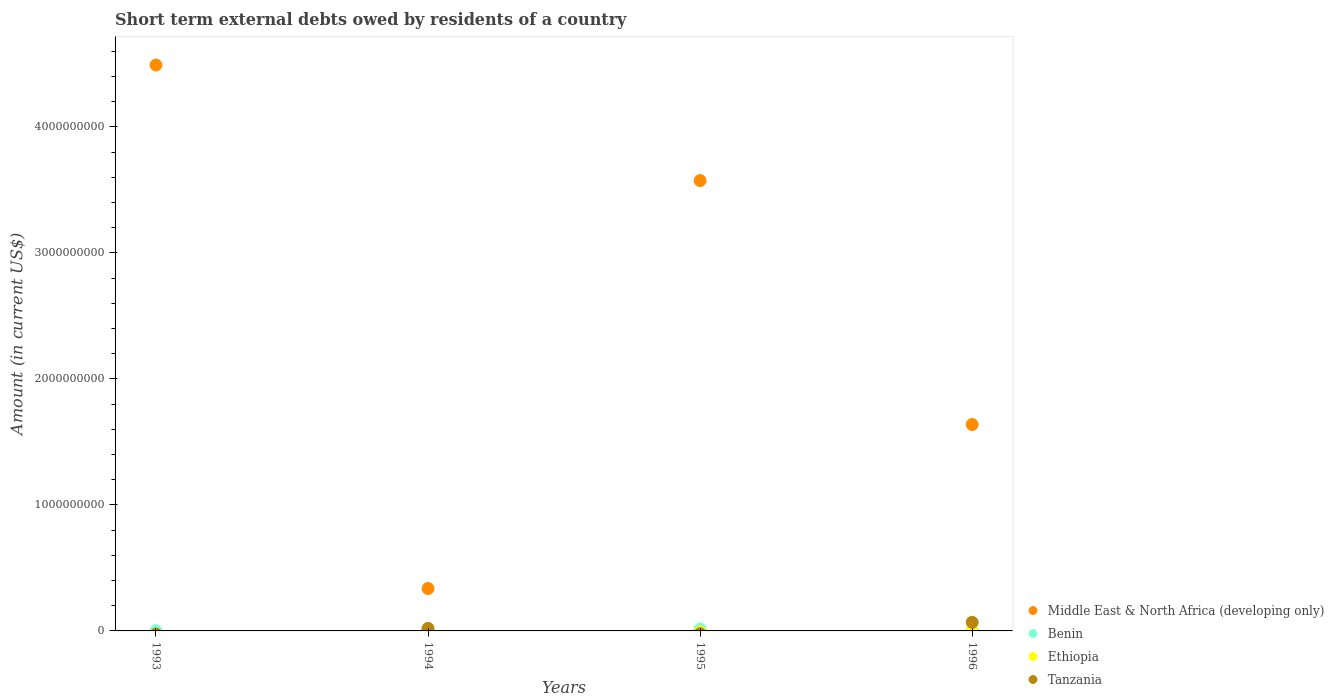Is the number of dotlines equal to the number of legend labels?
Your answer should be very brief. No. What is the amount of short-term external debts owed by residents in Benin in 1995?
Offer a terse response. 1.60e+07. Across all years, what is the maximum amount of short-term external debts owed by residents in Tanzania?
Provide a succinct answer. 6.81e+07. Across all years, what is the minimum amount of short-term external debts owed by residents in Middle East & North Africa (developing only)?
Ensure brevity in your answer.  3.36e+08. In which year was the amount of short-term external debts owed by residents in Middle East & North Africa (developing only) maximum?
Your response must be concise. 1993. What is the total amount of short-term external debts owed by residents in Benin in the graph?
Your response must be concise. 2.07e+07. What is the difference between the amount of short-term external debts owed by residents in Middle East & North Africa (developing only) in 1995 and that in 1996?
Your response must be concise. 1.94e+09. What is the difference between the amount of short-term external debts owed by residents in Middle East & North Africa (developing only) in 1994 and the amount of short-term external debts owed by residents in Tanzania in 1995?
Ensure brevity in your answer.  3.36e+08. What is the average amount of short-term external debts owed by residents in Tanzania per year?
Offer a very short reply. 2.20e+07. In the year 1993, what is the difference between the amount of short-term external debts owed by residents in Middle East & North Africa (developing only) and amount of short-term external debts owed by residents in Benin?
Make the answer very short. 4.49e+09. In how many years, is the amount of short-term external debts owed by residents in Middle East & North Africa (developing only) greater than 2000000000 US$?
Offer a very short reply. 2. What is the ratio of the amount of short-term external debts owed by residents in Middle East & North Africa (developing only) in 1995 to that in 1996?
Provide a short and direct response. 2.18. Is the amount of short-term external debts owed by residents in Benin in 1994 less than that in 1995?
Ensure brevity in your answer.  Yes. What is the difference between the highest and the second highest amount of short-term external debts owed by residents in Benin?
Your response must be concise. 1.33e+07. What is the difference between the highest and the lowest amount of short-term external debts owed by residents in Benin?
Offer a very short reply. 1.60e+07. Is the sum of the amount of short-term external debts owed by residents in Middle East & North Africa (developing only) in 1993 and 1996 greater than the maximum amount of short-term external debts owed by residents in Tanzania across all years?
Ensure brevity in your answer.  Yes. Does the amount of short-term external debts owed by residents in Ethiopia monotonically increase over the years?
Give a very brief answer. No. How many dotlines are there?
Offer a very short reply. 4. Are the values on the major ticks of Y-axis written in scientific E-notation?
Offer a very short reply. No. Does the graph contain grids?
Your answer should be very brief. No. Where does the legend appear in the graph?
Your answer should be compact. Bottom right. How many legend labels are there?
Make the answer very short. 4. How are the legend labels stacked?
Provide a succinct answer. Vertical. What is the title of the graph?
Ensure brevity in your answer.  Short term external debts owed by residents of a country. What is the label or title of the X-axis?
Keep it short and to the point. Years. What is the Amount (in current US$) in Middle East & North Africa (developing only) in 1993?
Keep it short and to the point. 4.49e+09. What is the Amount (in current US$) in Benin in 1993?
Provide a short and direct response. 1.97e+06. What is the Amount (in current US$) of Ethiopia in 1993?
Your answer should be compact. 0. What is the Amount (in current US$) of Middle East & North Africa (developing only) in 1994?
Keep it short and to the point. 3.36e+08. What is the Amount (in current US$) in Benin in 1994?
Give a very brief answer. 2.71e+06. What is the Amount (in current US$) of Ethiopia in 1994?
Your answer should be very brief. 2.30e+05. What is the Amount (in current US$) in Tanzania in 1994?
Ensure brevity in your answer.  1.99e+07. What is the Amount (in current US$) in Middle East & North Africa (developing only) in 1995?
Your answer should be very brief. 3.57e+09. What is the Amount (in current US$) in Benin in 1995?
Offer a very short reply. 1.60e+07. What is the Amount (in current US$) in Tanzania in 1995?
Provide a succinct answer. 0. What is the Amount (in current US$) in Middle East & North Africa (developing only) in 1996?
Provide a short and direct response. 1.64e+09. What is the Amount (in current US$) in Tanzania in 1996?
Ensure brevity in your answer.  6.81e+07. Across all years, what is the maximum Amount (in current US$) of Middle East & North Africa (developing only)?
Your answer should be very brief. 4.49e+09. Across all years, what is the maximum Amount (in current US$) of Benin?
Give a very brief answer. 1.60e+07. Across all years, what is the maximum Amount (in current US$) in Ethiopia?
Your answer should be compact. 2.30e+05. Across all years, what is the maximum Amount (in current US$) in Tanzania?
Your answer should be compact. 6.81e+07. Across all years, what is the minimum Amount (in current US$) in Middle East & North Africa (developing only)?
Give a very brief answer. 3.36e+08. Across all years, what is the minimum Amount (in current US$) of Ethiopia?
Offer a very short reply. 0. What is the total Amount (in current US$) of Middle East & North Africa (developing only) in the graph?
Keep it short and to the point. 1.00e+1. What is the total Amount (in current US$) in Benin in the graph?
Your answer should be very brief. 2.07e+07. What is the total Amount (in current US$) in Ethiopia in the graph?
Make the answer very short. 2.30e+05. What is the total Amount (in current US$) of Tanzania in the graph?
Give a very brief answer. 8.80e+07. What is the difference between the Amount (in current US$) of Middle East & North Africa (developing only) in 1993 and that in 1994?
Ensure brevity in your answer.  4.15e+09. What is the difference between the Amount (in current US$) in Benin in 1993 and that in 1994?
Your answer should be compact. -7.40e+05. What is the difference between the Amount (in current US$) of Middle East & North Africa (developing only) in 1993 and that in 1995?
Your answer should be very brief. 9.17e+08. What is the difference between the Amount (in current US$) of Benin in 1993 and that in 1995?
Ensure brevity in your answer.  -1.40e+07. What is the difference between the Amount (in current US$) in Middle East & North Africa (developing only) in 1993 and that in 1996?
Offer a terse response. 2.85e+09. What is the difference between the Amount (in current US$) in Middle East & North Africa (developing only) in 1994 and that in 1995?
Your answer should be very brief. -3.24e+09. What is the difference between the Amount (in current US$) in Benin in 1994 and that in 1995?
Offer a very short reply. -1.33e+07. What is the difference between the Amount (in current US$) in Middle East & North Africa (developing only) in 1994 and that in 1996?
Provide a short and direct response. -1.30e+09. What is the difference between the Amount (in current US$) in Tanzania in 1994 and that in 1996?
Ensure brevity in your answer.  -4.82e+07. What is the difference between the Amount (in current US$) in Middle East & North Africa (developing only) in 1995 and that in 1996?
Provide a short and direct response. 1.94e+09. What is the difference between the Amount (in current US$) of Middle East & North Africa (developing only) in 1993 and the Amount (in current US$) of Benin in 1994?
Keep it short and to the point. 4.49e+09. What is the difference between the Amount (in current US$) in Middle East & North Africa (developing only) in 1993 and the Amount (in current US$) in Ethiopia in 1994?
Ensure brevity in your answer.  4.49e+09. What is the difference between the Amount (in current US$) of Middle East & North Africa (developing only) in 1993 and the Amount (in current US$) of Tanzania in 1994?
Offer a very short reply. 4.47e+09. What is the difference between the Amount (in current US$) in Benin in 1993 and the Amount (in current US$) in Ethiopia in 1994?
Your answer should be very brief. 1.74e+06. What is the difference between the Amount (in current US$) in Benin in 1993 and the Amount (in current US$) in Tanzania in 1994?
Give a very brief answer. -1.79e+07. What is the difference between the Amount (in current US$) of Middle East & North Africa (developing only) in 1993 and the Amount (in current US$) of Benin in 1995?
Make the answer very short. 4.47e+09. What is the difference between the Amount (in current US$) of Middle East & North Africa (developing only) in 1993 and the Amount (in current US$) of Tanzania in 1996?
Make the answer very short. 4.42e+09. What is the difference between the Amount (in current US$) in Benin in 1993 and the Amount (in current US$) in Tanzania in 1996?
Give a very brief answer. -6.61e+07. What is the difference between the Amount (in current US$) of Middle East & North Africa (developing only) in 1994 and the Amount (in current US$) of Benin in 1995?
Provide a short and direct response. 3.20e+08. What is the difference between the Amount (in current US$) in Middle East & North Africa (developing only) in 1994 and the Amount (in current US$) in Tanzania in 1996?
Ensure brevity in your answer.  2.68e+08. What is the difference between the Amount (in current US$) of Benin in 1994 and the Amount (in current US$) of Tanzania in 1996?
Ensure brevity in your answer.  -6.54e+07. What is the difference between the Amount (in current US$) of Ethiopia in 1994 and the Amount (in current US$) of Tanzania in 1996?
Provide a short and direct response. -6.78e+07. What is the difference between the Amount (in current US$) in Middle East & North Africa (developing only) in 1995 and the Amount (in current US$) in Tanzania in 1996?
Provide a short and direct response. 3.51e+09. What is the difference between the Amount (in current US$) in Benin in 1995 and the Amount (in current US$) in Tanzania in 1996?
Offer a very short reply. -5.21e+07. What is the average Amount (in current US$) in Middle East & North Africa (developing only) per year?
Give a very brief answer. 2.51e+09. What is the average Amount (in current US$) in Benin per year?
Your answer should be compact. 5.16e+06. What is the average Amount (in current US$) of Ethiopia per year?
Provide a succinct answer. 5.75e+04. What is the average Amount (in current US$) in Tanzania per year?
Your response must be concise. 2.20e+07. In the year 1993, what is the difference between the Amount (in current US$) in Middle East & North Africa (developing only) and Amount (in current US$) in Benin?
Ensure brevity in your answer.  4.49e+09. In the year 1994, what is the difference between the Amount (in current US$) in Middle East & North Africa (developing only) and Amount (in current US$) in Benin?
Offer a terse response. 3.34e+08. In the year 1994, what is the difference between the Amount (in current US$) of Middle East & North Africa (developing only) and Amount (in current US$) of Ethiopia?
Offer a very short reply. 3.36e+08. In the year 1994, what is the difference between the Amount (in current US$) of Middle East & North Africa (developing only) and Amount (in current US$) of Tanzania?
Provide a short and direct response. 3.16e+08. In the year 1994, what is the difference between the Amount (in current US$) in Benin and Amount (in current US$) in Ethiopia?
Ensure brevity in your answer.  2.48e+06. In the year 1994, what is the difference between the Amount (in current US$) in Benin and Amount (in current US$) in Tanzania?
Offer a very short reply. -1.72e+07. In the year 1994, what is the difference between the Amount (in current US$) of Ethiopia and Amount (in current US$) of Tanzania?
Offer a very short reply. -1.97e+07. In the year 1995, what is the difference between the Amount (in current US$) of Middle East & North Africa (developing only) and Amount (in current US$) of Benin?
Provide a succinct answer. 3.56e+09. In the year 1996, what is the difference between the Amount (in current US$) in Middle East & North Africa (developing only) and Amount (in current US$) in Tanzania?
Make the answer very short. 1.57e+09. What is the ratio of the Amount (in current US$) of Middle East & North Africa (developing only) in 1993 to that in 1994?
Give a very brief answer. 13.35. What is the ratio of the Amount (in current US$) of Benin in 1993 to that in 1994?
Give a very brief answer. 0.73. What is the ratio of the Amount (in current US$) in Middle East & North Africa (developing only) in 1993 to that in 1995?
Your answer should be compact. 1.26. What is the ratio of the Amount (in current US$) in Benin in 1993 to that in 1995?
Make the answer very short. 0.12. What is the ratio of the Amount (in current US$) in Middle East & North Africa (developing only) in 1993 to that in 1996?
Keep it short and to the point. 2.74. What is the ratio of the Amount (in current US$) in Middle East & North Africa (developing only) in 1994 to that in 1995?
Your response must be concise. 0.09. What is the ratio of the Amount (in current US$) of Benin in 1994 to that in 1995?
Offer a very short reply. 0.17. What is the ratio of the Amount (in current US$) of Middle East & North Africa (developing only) in 1994 to that in 1996?
Provide a short and direct response. 0.21. What is the ratio of the Amount (in current US$) in Tanzania in 1994 to that in 1996?
Give a very brief answer. 0.29. What is the ratio of the Amount (in current US$) of Middle East & North Africa (developing only) in 1995 to that in 1996?
Keep it short and to the point. 2.18. What is the difference between the highest and the second highest Amount (in current US$) of Middle East & North Africa (developing only)?
Your response must be concise. 9.17e+08. What is the difference between the highest and the second highest Amount (in current US$) in Benin?
Provide a succinct answer. 1.33e+07. What is the difference between the highest and the lowest Amount (in current US$) in Middle East & North Africa (developing only)?
Your answer should be compact. 4.15e+09. What is the difference between the highest and the lowest Amount (in current US$) in Benin?
Keep it short and to the point. 1.60e+07. What is the difference between the highest and the lowest Amount (in current US$) in Tanzania?
Give a very brief answer. 6.81e+07. 